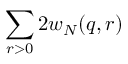<formula> <loc_0><loc_0><loc_500><loc_500>\sum _ { r > 0 } 2 w _ { N } ( q , r )</formula> 